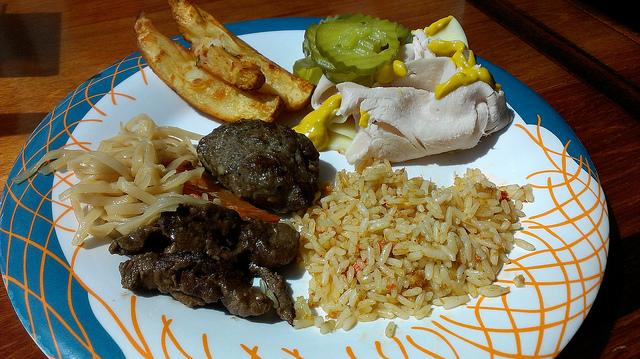What is green on the plate?
Short answer required. Pickles. Has the drink spilled on to the plate with the food?
Short answer required. No. Would you like to have meal like that?
Quick response, please. Yes. 